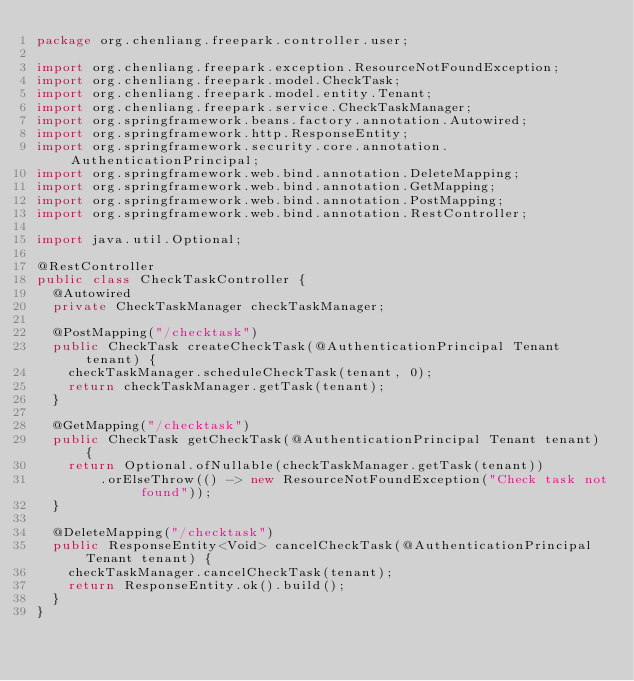<code> <loc_0><loc_0><loc_500><loc_500><_Java_>package org.chenliang.freepark.controller.user;

import org.chenliang.freepark.exception.ResourceNotFoundException;
import org.chenliang.freepark.model.CheckTask;
import org.chenliang.freepark.model.entity.Tenant;
import org.chenliang.freepark.service.CheckTaskManager;
import org.springframework.beans.factory.annotation.Autowired;
import org.springframework.http.ResponseEntity;
import org.springframework.security.core.annotation.AuthenticationPrincipal;
import org.springframework.web.bind.annotation.DeleteMapping;
import org.springframework.web.bind.annotation.GetMapping;
import org.springframework.web.bind.annotation.PostMapping;
import org.springframework.web.bind.annotation.RestController;

import java.util.Optional;

@RestController
public class CheckTaskController {
  @Autowired
  private CheckTaskManager checkTaskManager;

  @PostMapping("/checktask")
  public CheckTask createCheckTask(@AuthenticationPrincipal Tenant tenant) {
    checkTaskManager.scheduleCheckTask(tenant, 0);
    return checkTaskManager.getTask(tenant);
  }

  @GetMapping("/checktask")
  public CheckTask getCheckTask(@AuthenticationPrincipal Tenant tenant) {
    return Optional.ofNullable(checkTaskManager.getTask(tenant))
        .orElseThrow(() -> new ResourceNotFoundException("Check task not found"));
  }

  @DeleteMapping("/checktask")
  public ResponseEntity<Void> cancelCheckTask(@AuthenticationPrincipal Tenant tenant) {
    checkTaskManager.cancelCheckTask(tenant);
    return ResponseEntity.ok().build();
  }
}
</code> 